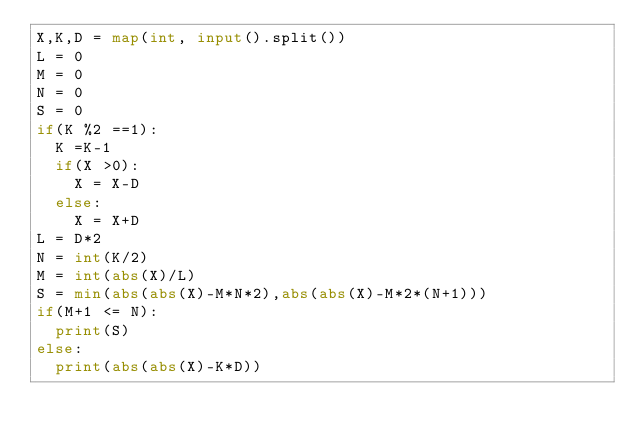Convert code to text. <code><loc_0><loc_0><loc_500><loc_500><_Python_>X,K,D = map(int, input().split())
L = 0
M = 0
N = 0
S = 0
if(K %2 ==1):
  K =K-1
  if(X >0):
    X = X-D
  else:
    X = X+D
L = D*2
N = int(K/2)
M = int(abs(X)/L)
S = min(abs(abs(X)-M*N*2),abs(abs(X)-M*2*(N+1)))
if(M+1 <= N):
  print(S)
else:
  print(abs(abs(X)-K*D))</code> 